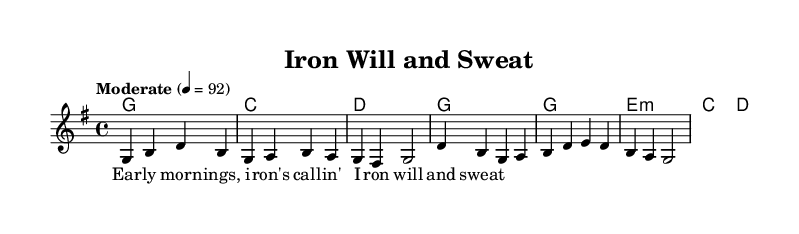What is the key signature of this music? The key signature is G major, which has one sharp (F#).
Answer: G major What is the time signature of the piece? The time signature is 4/4, which means there are four beats in each measure and the quarter note gets one beat.
Answer: 4/4 What is the tempo marking for this piece? The tempo marking is "Moderate" with a metronome setting of 92 beats per minute, indicating a moderate speed for the performance.
Answer: Moderate 4 = 92 How many chords are used in the verse? The verse consists of four different chords: G, C, D, and G again.
Answer: Four What is the first lyric of the song? The first lyric in the verse is "Ear". It is the opening word of the line indicating the theme of the song in relation to early morning and commitment.
Answer: Ear What is the range of the melody? The melody spans from G4 to D'4, moving within the G major scale, which reflects the typical vocal range used in country music.
Answer: G4 to D'4 How many measures are in the chorus section? The chorus section contains a total of four measures, outlining a repetitive and catchy structure typical in country tunes.
Answer: Four 